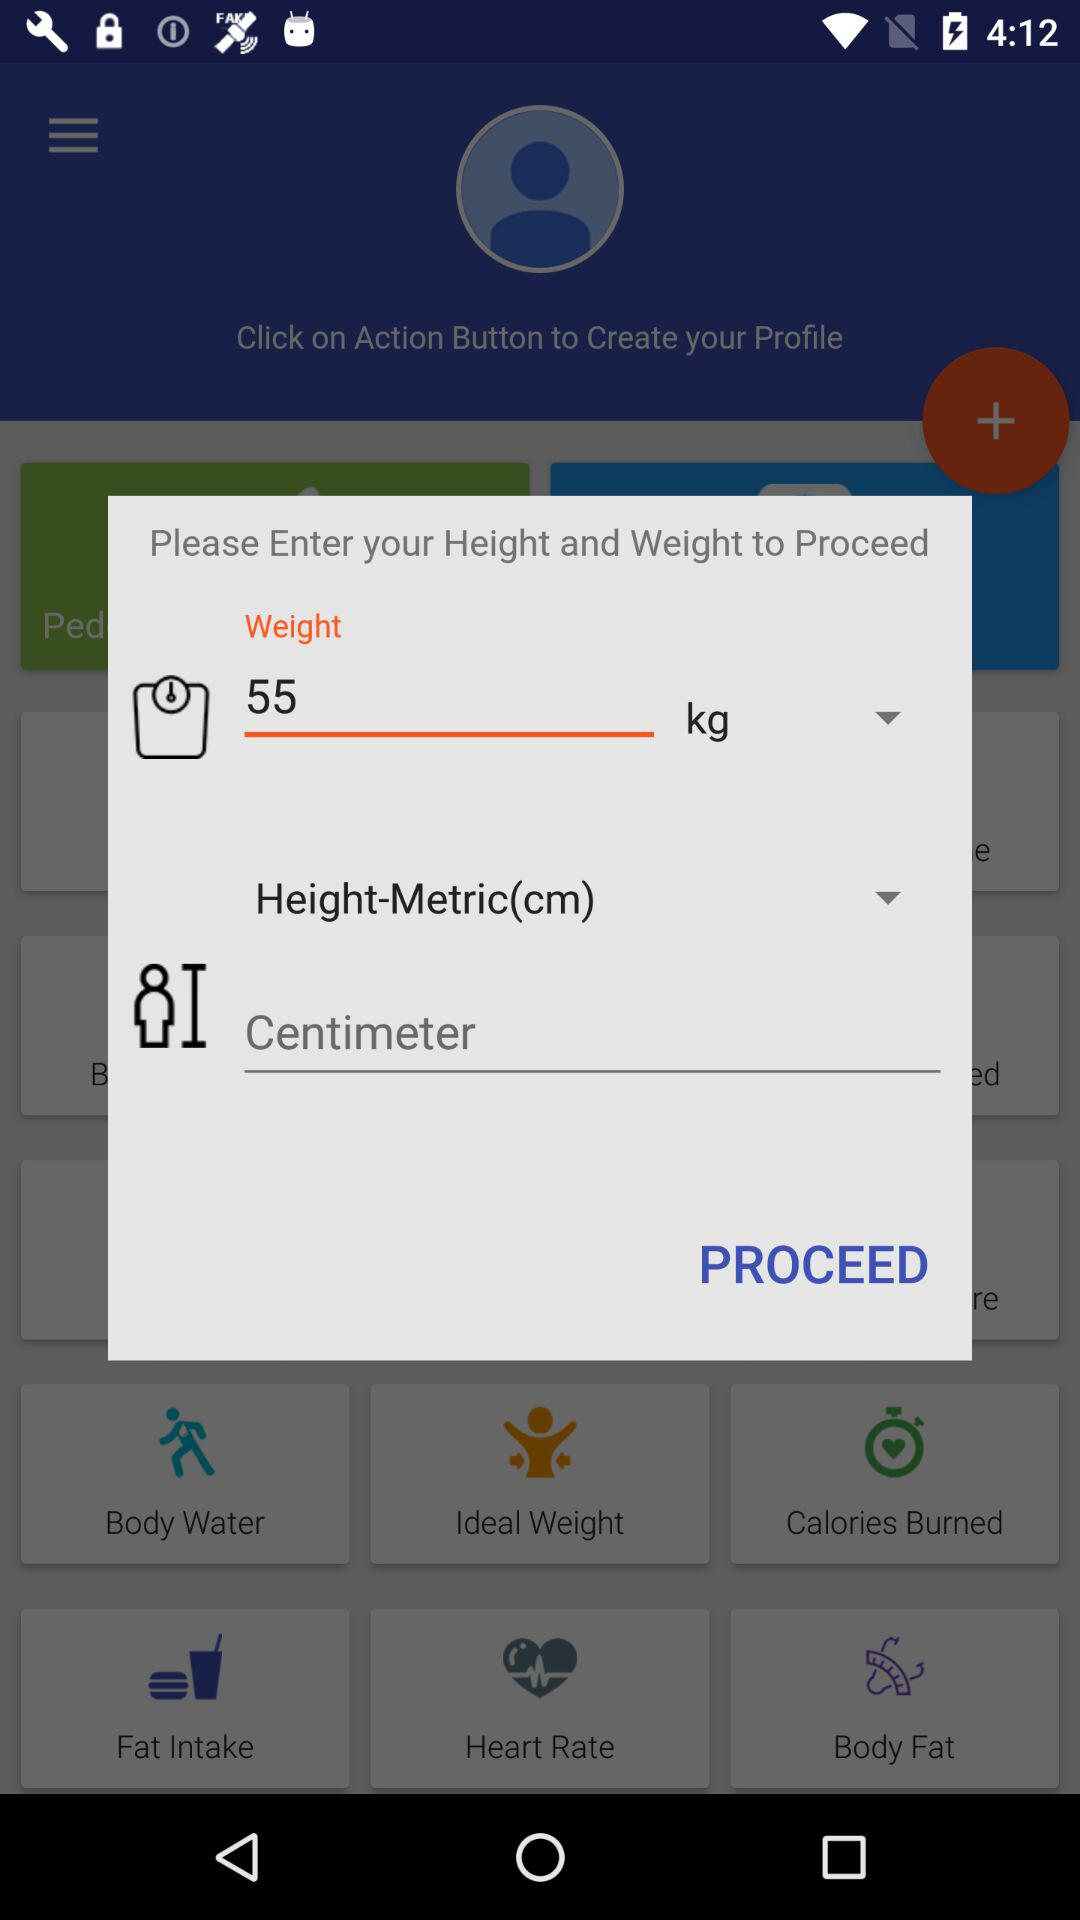What is the weight in kilograms? The weight in kilograms is 55. 